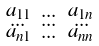Convert formula to latex. <formula><loc_0><loc_0><loc_500><loc_500>\begin{smallmatrix} a _ { 1 1 } & \dots & a _ { 1 n } \\ \dots & \dots & \dots \\ a _ { n 1 } & \dots & a _ { n n } \\ \end{smallmatrix}</formula> 